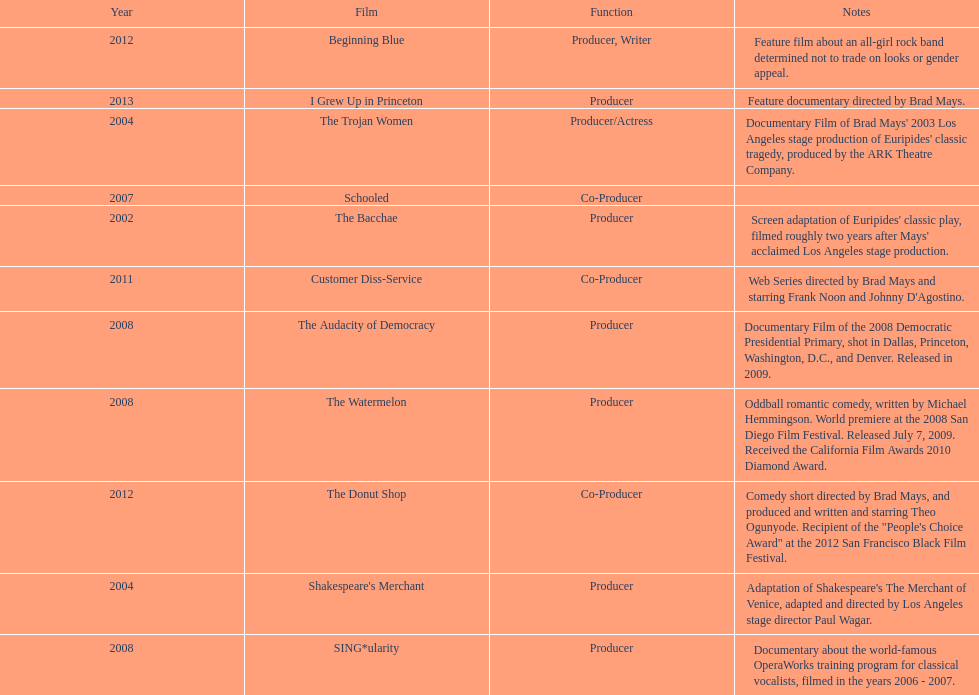How many years before was the film bacchae out before the watermelon? 6. 